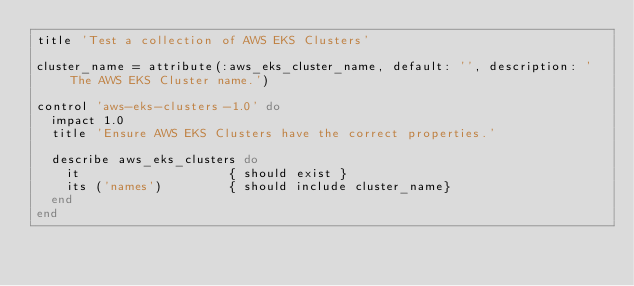<code> <loc_0><loc_0><loc_500><loc_500><_Ruby_>title 'Test a collection of AWS EKS Clusters'

cluster_name = attribute(:aws_eks_cluster_name, default: '', description: 'The AWS EKS Cluster name.')

control 'aws-eks-clusters-1.0' do
  impact 1.0
  title 'Ensure AWS EKS Clusters have the correct properties.'

  describe aws_eks_clusters do
    it                    { should exist }
    its ('names')         { should include cluster_name}
  end
end
</code> 